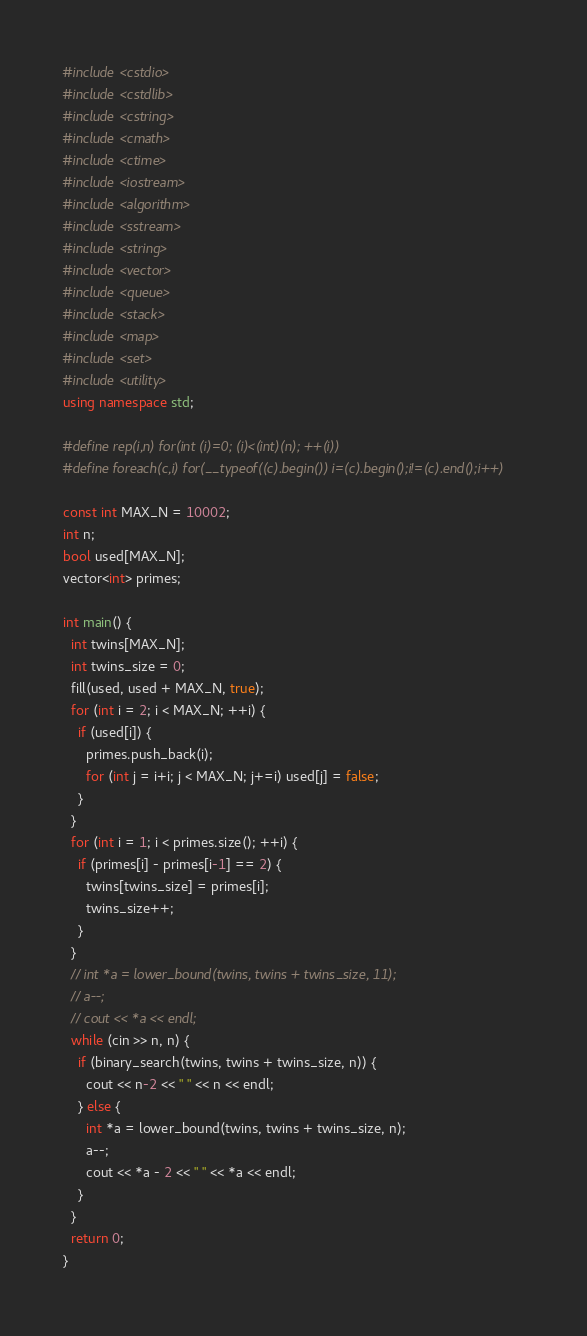<code> <loc_0><loc_0><loc_500><loc_500><_C++_>#include <cstdio>
#include <cstdlib>
#include <cstring>
#include <cmath>
#include <ctime>
#include <iostream>
#include <algorithm>
#include <sstream>
#include <string>
#include <vector>
#include <queue>
#include <stack>
#include <map>
#include <set>
#include <utility>
using namespace std;

#define rep(i,n) for(int (i)=0; (i)<(int)(n); ++(i))
#define foreach(c,i) for(__typeof((c).begin()) i=(c).begin();i!=(c).end();i++)

const int MAX_N = 10002;
int n;
bool used[MAX_N];
vector<int> primes;

int main() {
  int twins[MAX_N];
  int twins_size = 0;
  fill(used, used + MAX_N, true);
  for (int i = 2; i < MAX_N; ++i) {
    if (used[i]) {
      primes.push_back(i);
      for (int j = i+i; j < MAX_N; j+=i) used[j] = false;
    }
  }
  for (int i = 1; i < primes.size(); ++i) {
    if (primes[i] - primes[i-1] == 2) {
      twins[twins_size] = primes[i];
      twins_size++;
    }
  }
  // int *a = lower_bound(twins, twins + twins_size, 11);
  // a--;
  // cout << *a << endl;
  while (cin >> n, n) {
    if (binary_search(twins, twins + twins_size, n)) {
      cout << n-2 << " " << n << endl;
    } else {
      int *a = lower_bound(twins, twins + twins_size, n);
      a--;
      cout << *a - 2 << " " << *a << endl;
    }
  }
  return 0;
}</code> 